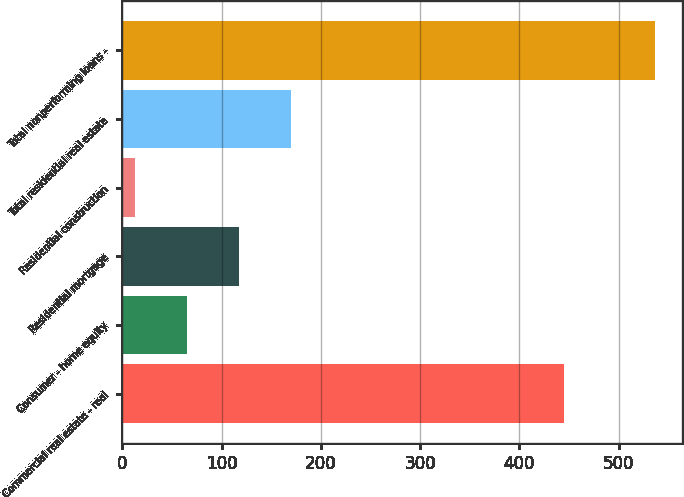<chart> <loc_0><loc_0><loc_500><loc_500><bar_chart><fcel>Commercial real estate - real<fcel>Consumer - home equity<fcel>Residential mortgage<fcel>Residential construction<fcel>Total residential real estate<fcel>Total nonperforming loans -<nl><fcel>445<fcel>65.4<fcel>117.8<fcel>13<fcel>170.2<fcel>537<nl></chart> 